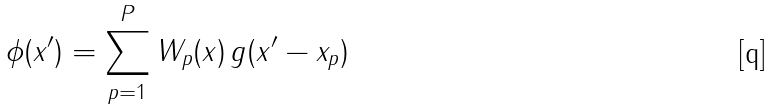Convert formula to latex. <formula><loc_0><loc_0><loc_500><loc_500>\phi ( x ^ { \prime } ) = \sum _ { p = 1 } ^ { P } W _ { p } ( x ) \, g ( x ^ { \prime } - x _ { p } )</formula> 